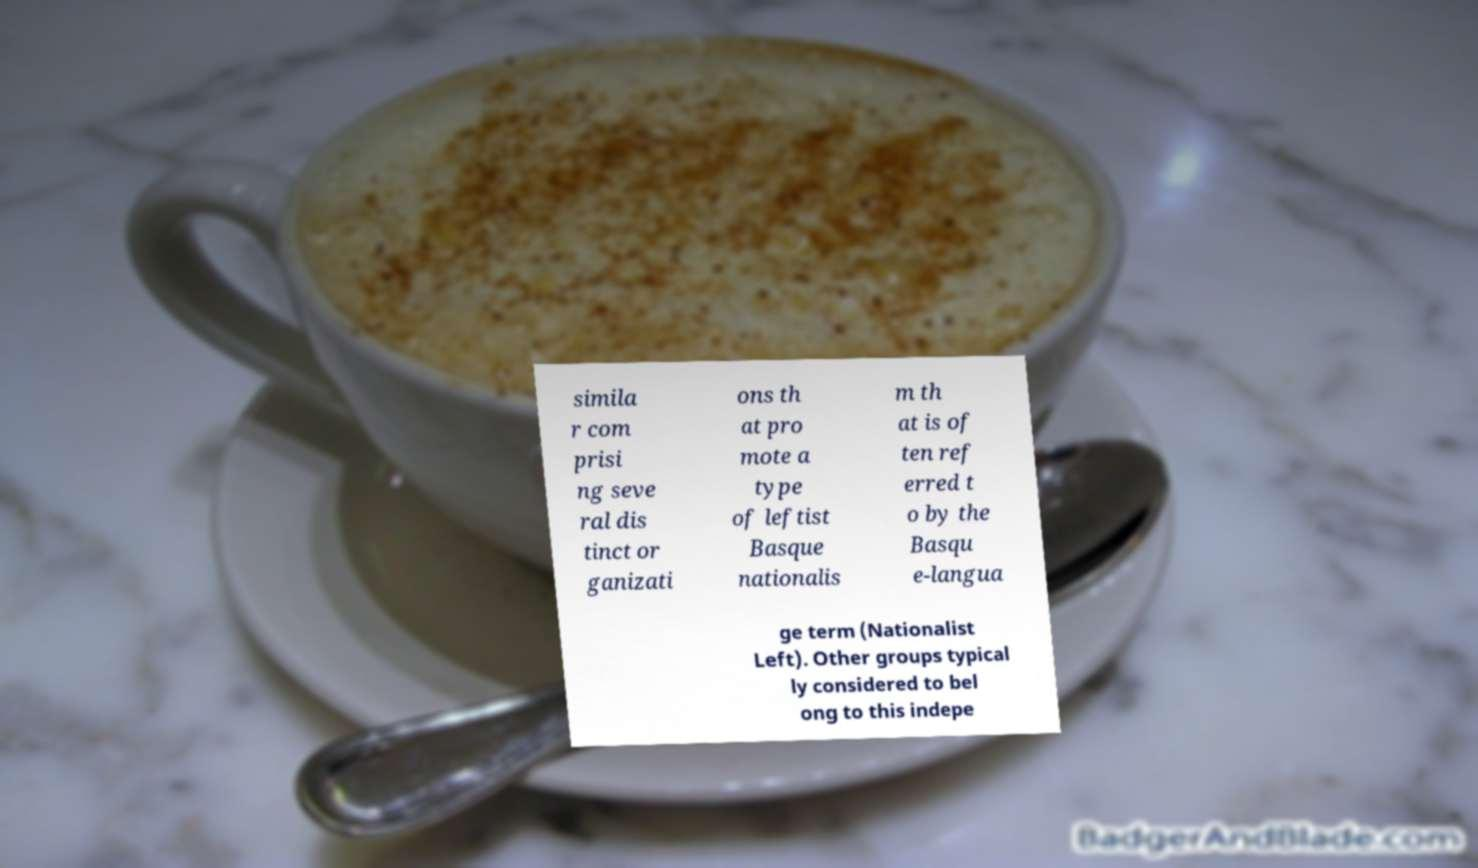Could you assist in decoding the text presented in this image and type it out clearly? simila r com prisi ng seve ral dis tinct or ganizati ons th at pro mote a type of leftist Basque nationalis m th at is of ten ref erred t o by the Basqu e-langua ge term (Nationalist Left). Other groups typical ly considered to bel ong to this indepe 